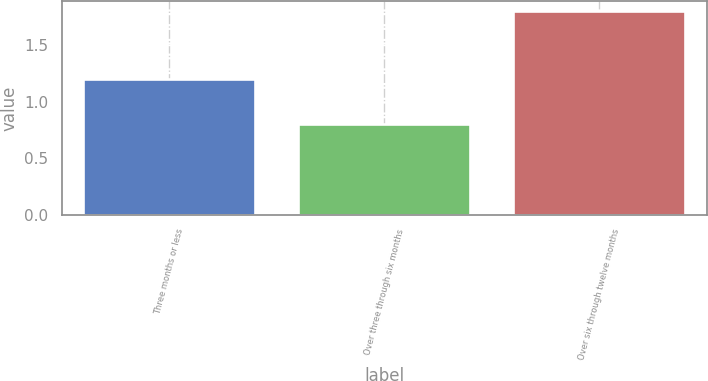Convert chart to OTSL. <chart><loc_0><loc_0><loc_500><loc_500><bar_chart><fcel>Three months or less<fcel>Over three through six months<fcel>Over six through twelve months<nl><fcel>1.2<fcel>0.8<fcel>1.8<nl></chart> 